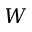Convert formula to latex. <formula><loc_0><loc_0><loc_500><loc_500>W</formula> 